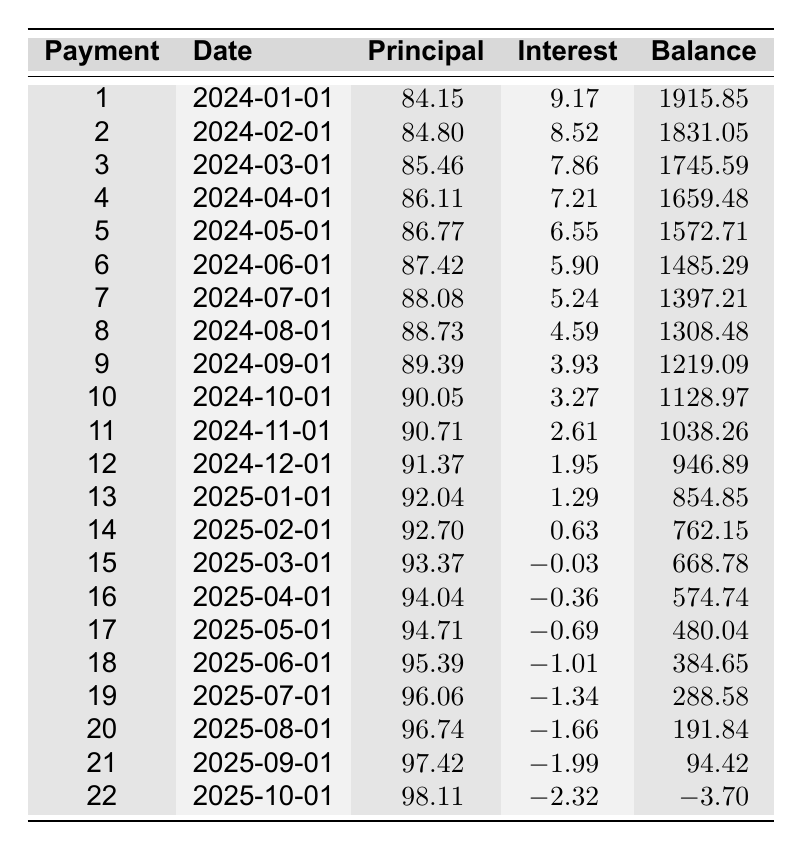What is the monthly payment amount for this loan? The table provides a clear reference in the loan details section showing that the monthly payment is 92.82.
Answer: 92.82 How much principal was paid in the 10th payment? By reviewing the 10th row of the schedule, the principal payment is listed as 90.05.
Answer: 90.05 What is the remaining balance after the first payment? The first payment row indicates a remaining balance of 1915.85 after the first payment is made.
Answer: 1915.85 What is the total interest paid over the first six months? To find the total interest, sum the interest payments from the first six rows: 9.17 + 8.52 + 7.86 + 7.21 + 6.55 + 5.90 = 45.21.
Answer: 45.21 Did the interest payment for the 16th payment decrease compared to the 15th payment? Comparing the interest payments of the 15th (0.03) and 16th (-0.36), the interest payment decreased from 0.03 to -0.36, confirming a decrease.
Answer: Yes What is the average principal payment over the last three months? The last three months’ principal payments are: 97.42 (September) + 98.11 (October) + 98.11 (last month) = 293.64. There are three months, so the average is 293.64 / 3 = 97.88.
Answer: 97.88 Is the remaining balance at the end of the 12th payment positive? The remaining balance after the 12th payment is 946.89, which is a positive value.
Answer: Yes What is the minimum remaining balance recorded during the loan period? To find the minimum remaining balance, inspect each row. The values reach their lowest at -3.70 after the 22nd payment.
Answer: -3.70 How much total principal is paid by the end of the first year (12 payments)? The total principal paid in the first 12 months can be calculated by adding each of the 12 principal payments, resulting in: 84.15 + 84.80 + 85.46 + 86.11 + 86.77 + 87.42 + 88.08 + 88.73 + 89.39 + 90.05 + 90.71 + 91.37 = 1048.23.
Answer: 1048.23 